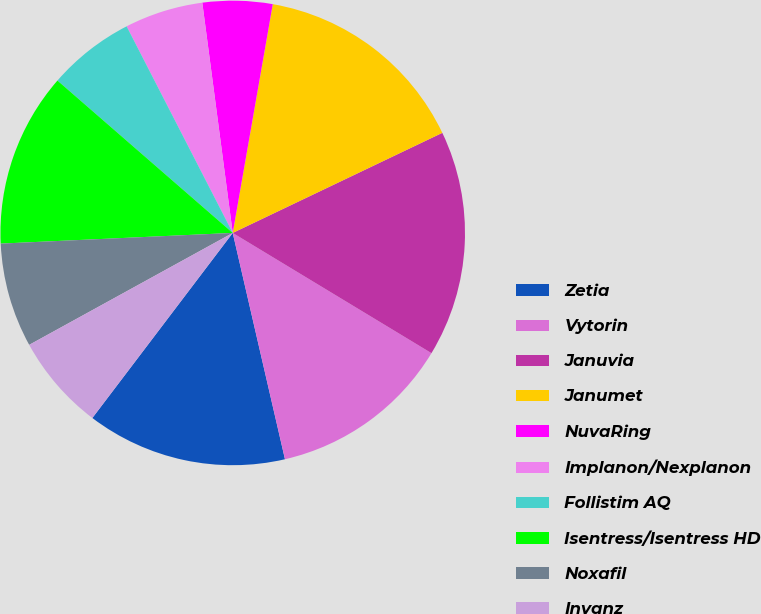<chart> <loc_0><loc_0><loc_500><loc_500><pie_chart><fcel>Zetia<fcel>Vytorin<fcel>Januvia<fcel>Janumet<fcel>NuvaRing<fcel>Implanon/Nexplanon<fcel>Follistim AQ<fcel>Isentress/Isentress HD<fcel>Noxafil<fcel>Invanz<nl><fcel>13.94%<fcel>12.73%<fcel>15.75%<fcel>15.15%<fcel>4.85%<fcel>5.46%<fcel>6.06%<fcel>12.12%<fcel>7.27%<fcel>6.67%<nl></chart> 